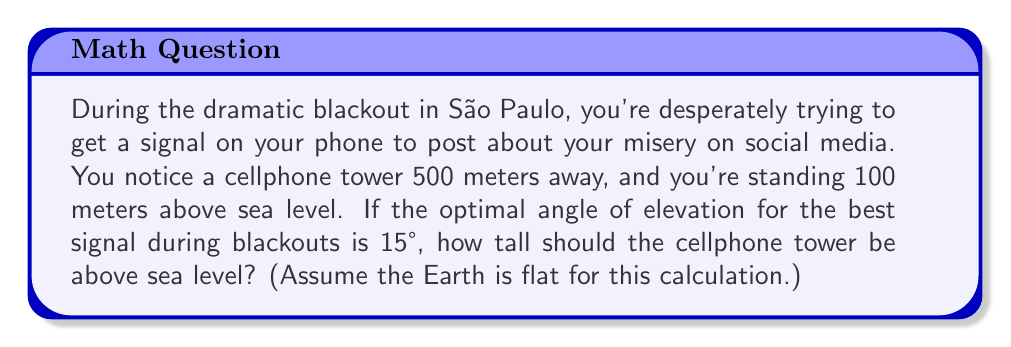Give your solution to this math problem. Let's approach this step-by-step:

1) First, let's visualize the problem:

[asy]
import geometry;

size(200);
pair A = (0,0);
pair B = (5,0);
pair C = (5,1);
pair D = (5,x);

draw(A--B--D--A);
draw(B--C,dashed);

label("You", A, SW);
label("Tower", D, E);
label("Sea Level", (2.5,0), S);
label("100m", (0,0.5), W);
label("500m", (2.5,0), N);
label("$h$", (5,0.5), E);
label("15°", (0.3,0.1), NE);

dot("A",A,SW);
dot("B",B,SE);
dot("C",C,SE);
dot("D",D,SE);

markangle(B,A,D,radius=0.5);
[/asy]

2) We can use the tangent function to solve this problem. The tangent of an angle in a right triangle is the ratio of the opposite side to the adjacent side.

3) In this case:
   - The angle of elevation is 15°
   - The adjacent side is 500 meters (the horizontal distance to the tower)
   - The opposite side is the height difference between you and the top of the tower

4) Let's call the height of the tower above sea level $h$. Then the height difference between you and the top of the tower is $(h - 100)$ meters.

5) We can write the equation:

   $$\tan(15°) = \frac{h - 100}{500}$$

6) Solving for $h$:
   
   $$h - 100 = 500 \tan(15°)$$
   $$h = 500 \tan(15°) + 100$$

7) Now we can calculate:
   $$h = 500 \times 0.26794 + 100$$
   $$h = 133.97 + 100 = 233.97$$

8) Rounding to the nearest meter:
   $$h \approx 234 \text{ meters}$$
Answer: The cellphone tower should be approximately 234 meters above sea level for optimal signal during blackouts. 